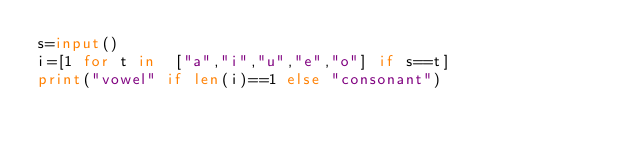Convert code to text. <code><loc_0><loc_0><loc_500><loc_500><_Python_>s=input()
i=[1 for t in  ["a","i","u","e","o"] if s==t]
print("vowel" if len(i)==1 else "consonant")</code> 